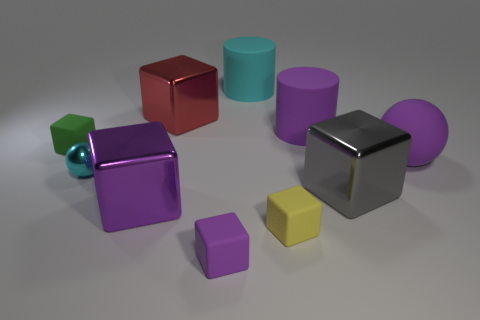How many things are either objects that are behind the big ball or large metallic things behind the tiny cyan metal thing?
Ensure brevity in your answer.  4. What number of objects are either brown blocks or large objects on the right side of the tiny green block?
Provide a short and direct response. 6. There is a rubber block left of the cyan thing that is in front of the small object behind the cyan sphere; what size is it?
Give a very brief answer. Small. What material is the cyan cylinder that is the same size as the purple cylinder?
Make the answer very short. Rubber. Is there a green rubber object of the same size as the cyan metal ball?
Give a very brief answer. Yes. There is a rubber object that is behind the purple cylinder; is it the same size as the large gray thing?
Ensure brevity in your answer.  Yes. There is a tiny thing that is to the left of the yellow object and on the right side of the cyan shiny ball; what is its shape?
Make the answer very short. Cube. Is the number of cyan rubber things that are in front of the tiny green rubber object greater than the number of red blocks?
Make the answer very short. No. The gray thing that is the same material as the large red block is what size?
Your response must be concise. Large. How many large balls are the same color as the tiny sphere?
Make the answer very short. 0. 